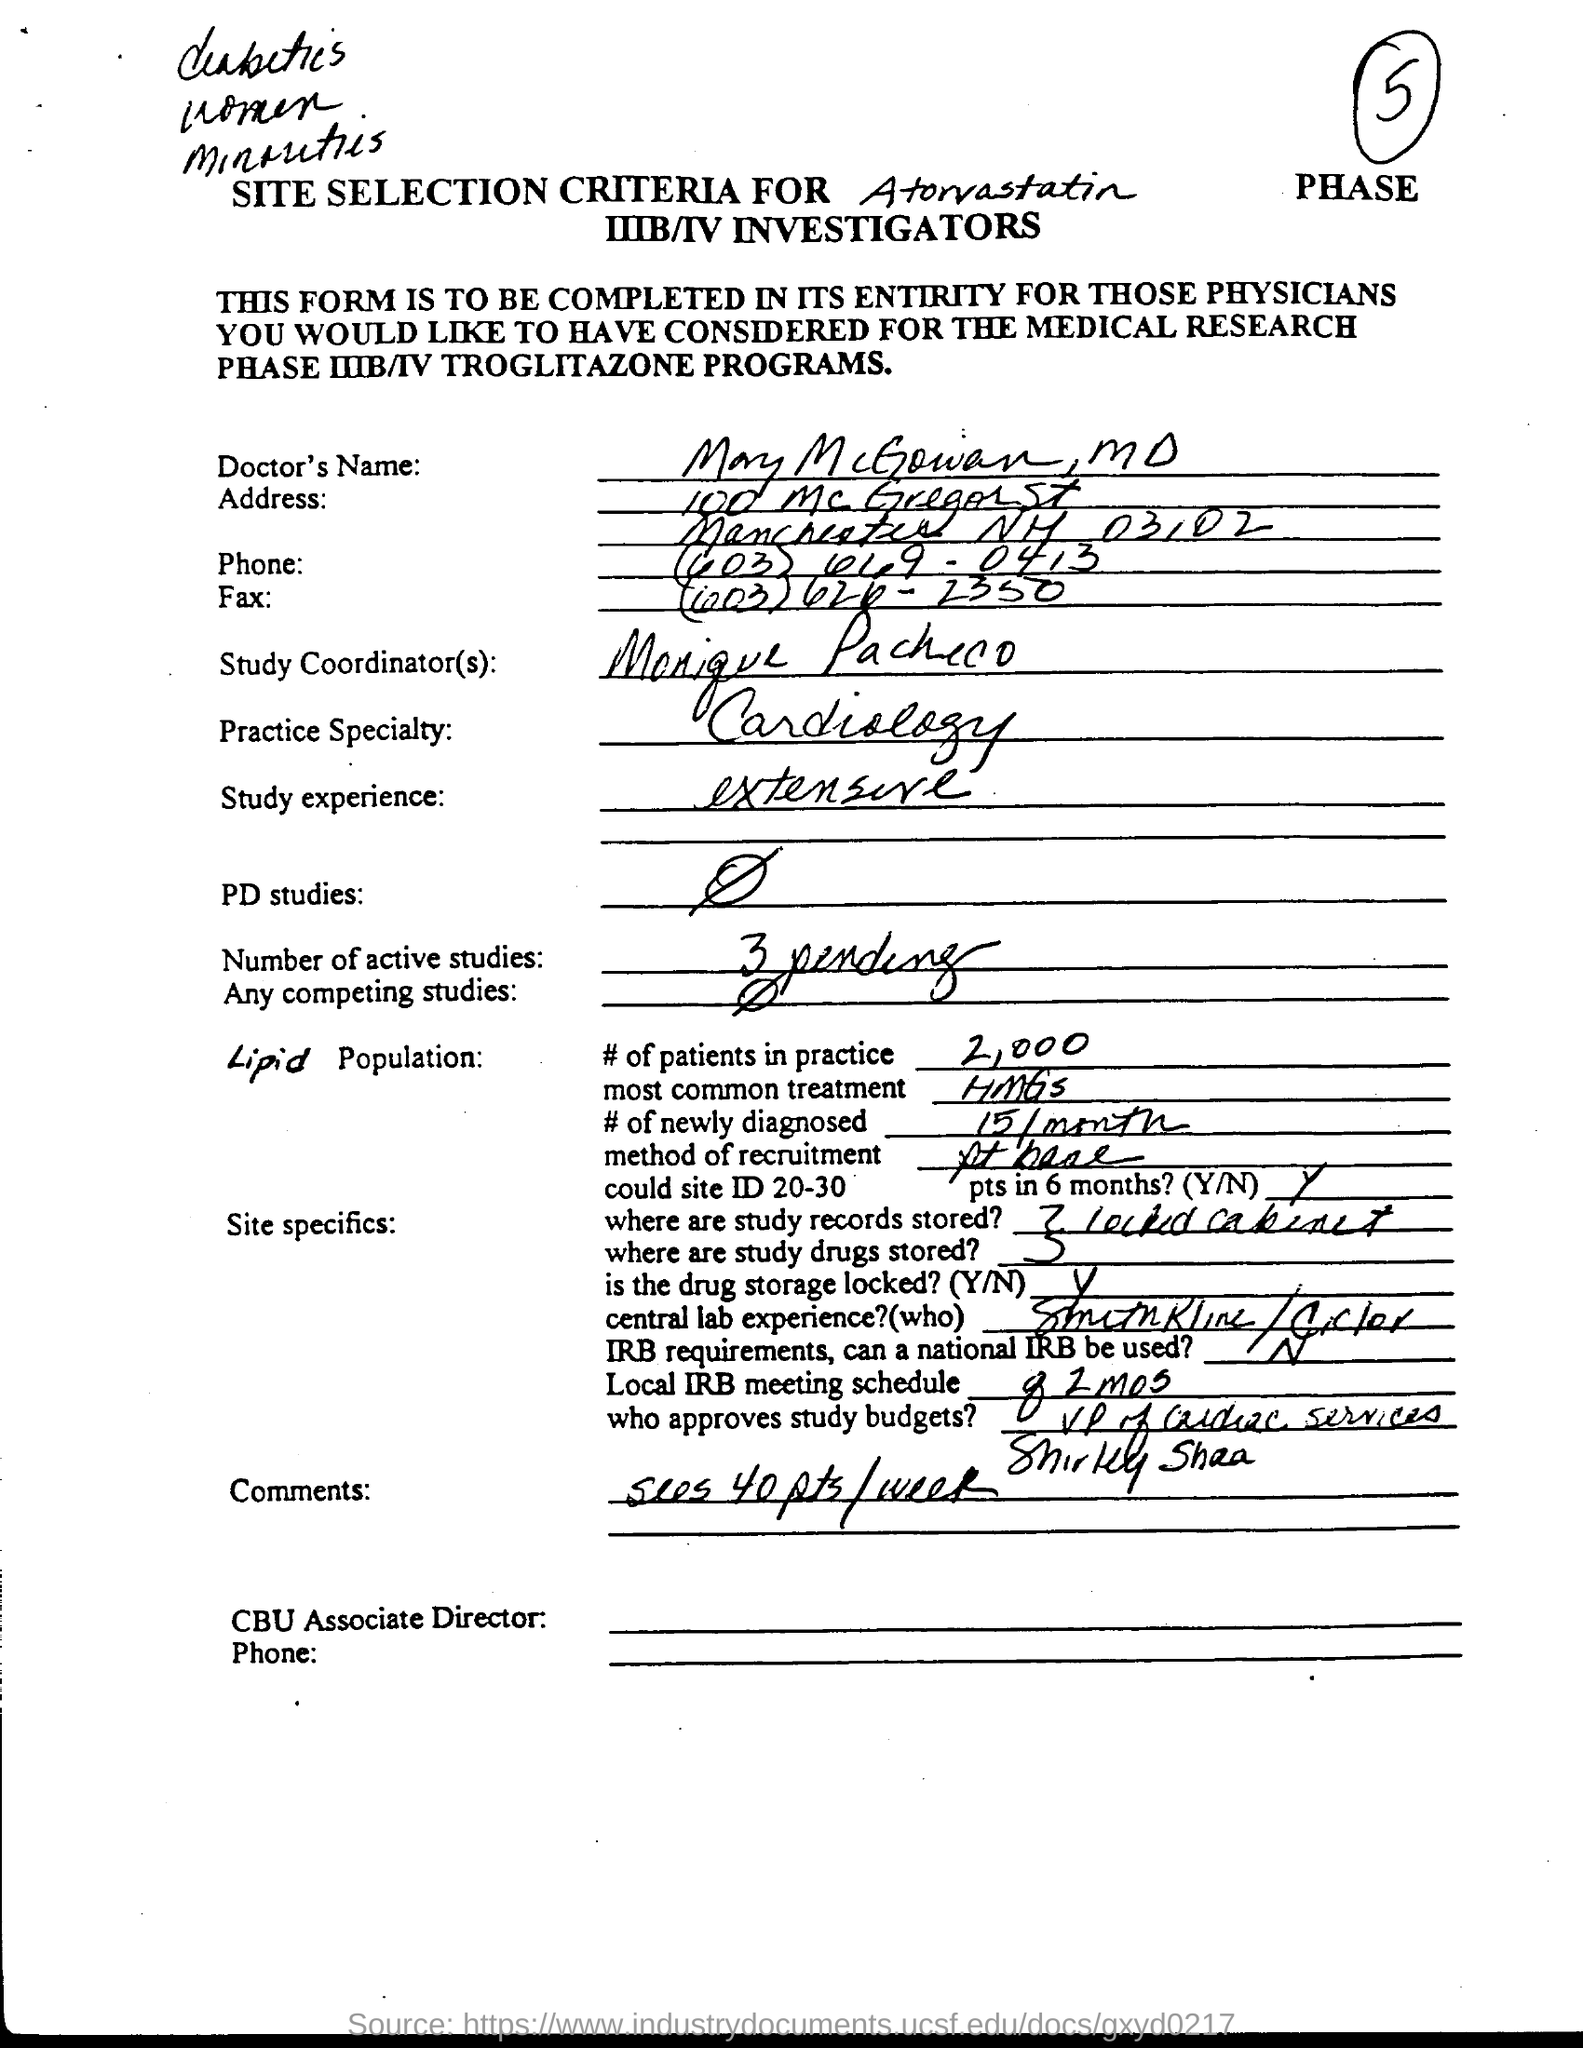What is the Study experience?
Offer a very short reply. Extensive. What is the number of active studies?
Offer a very short reply. 3 pending. 